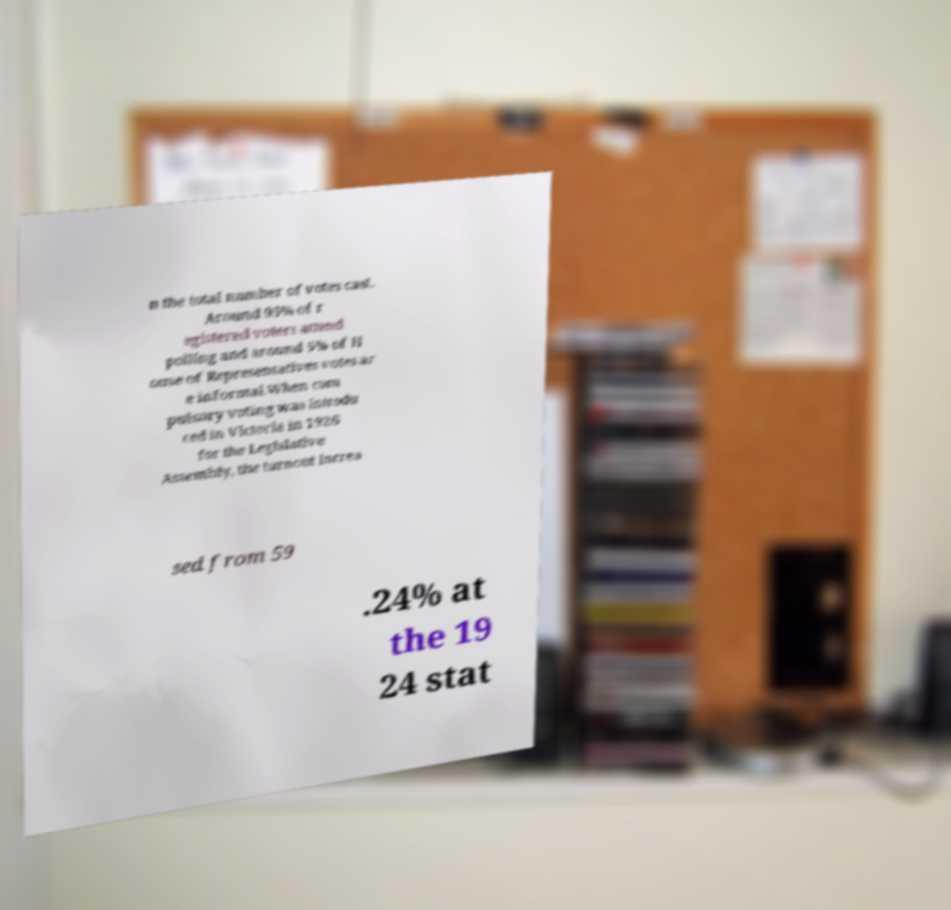There's text embedded in this image that I need extracted. Can you transcribe it verbatim? n the total number of votes cast. Around 95% of r egistered voters attend polling and around 5% of H ouse of Representatives votes ar e informal.When com pulsory voting was introdu ced in Victoria in 1926 for the Legislative Assembly, the turnout increa sed from 59 .24% at the 19 24 stat 